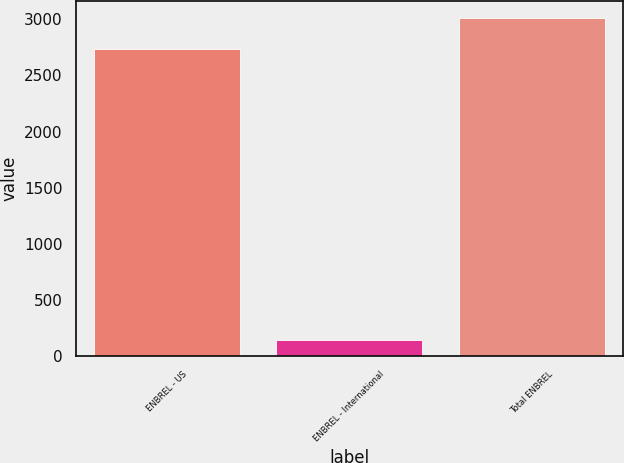Convert chart. <chart><loc_0><loc_0><loc_500><loc_500><bar_chart><fcel>ENBREL - US<fcel>ENBREL - International<fcel>Total ENBREL<nl><fcel>2736<fcel>143<fcel>3009.6<nl></chart> 